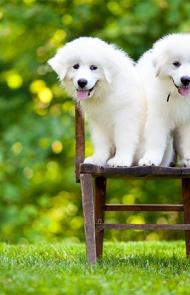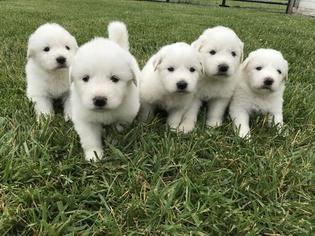The first image is the image on the left, the second image is the image on the right. Examine the images to the left and right. Is the description "There are no more than two dogs." accurate? Answer yes or no. No. The first image is the image on the left, the second image is the image on the right. Assess this claim about the two images: "There is exactly one dog in each image.". Correct or not? Answer yes or no. No. 